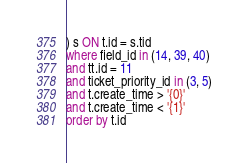Convert code to text. <code><loc_0><loc_0><loc_500><loc_500><_SQL_>) s ON t.id = s.tid
where field_id in (14, 39, 40)
and tt.id = 11
and ticket_priority_id in (3, 5)
and t.create_time > '{0}'
and t.create_time < '{1}'
order by t.id</code> 